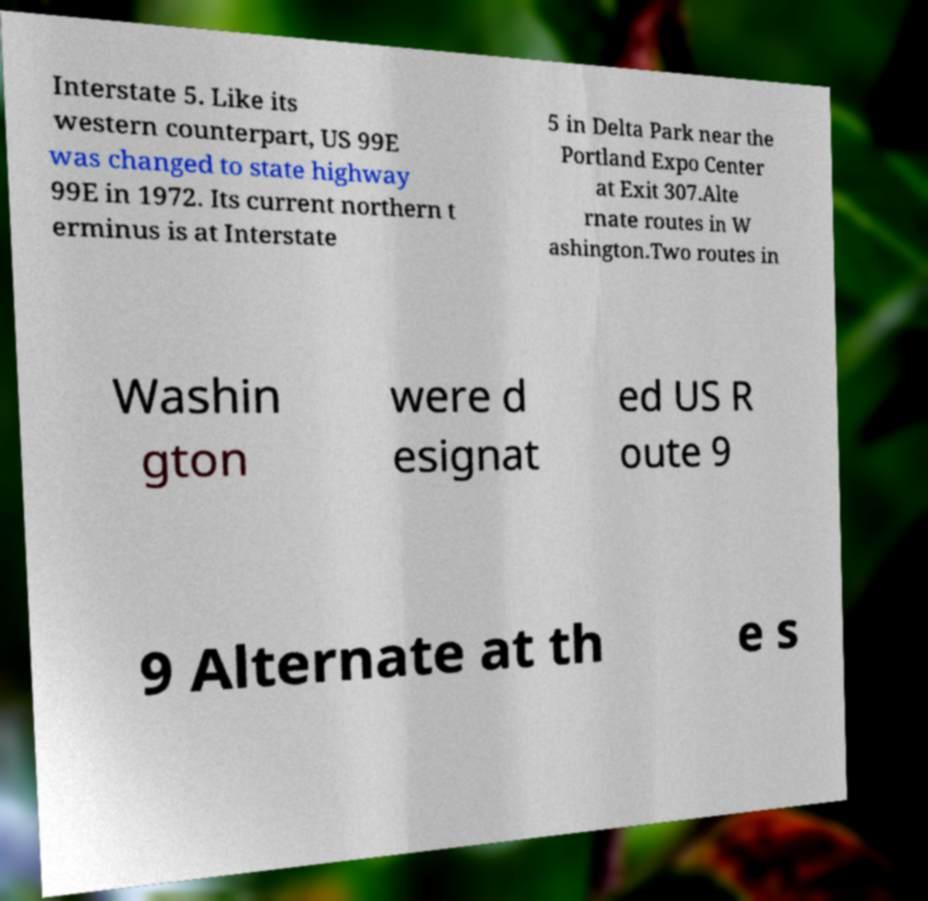I need the written content from this picture converted into text. Can you do that? Interstate 5. Like its western counterpart, US 99E was changed to state highway 99E in 1972. Its current northern t erminus is at Interstate 5 in Delta Park near the Portland Expo Center at Exit 307.Alte rnate routes in W ashington.Two routes in Washin gton were d esignat ed US R oute 9 9 Alternate at th e s 